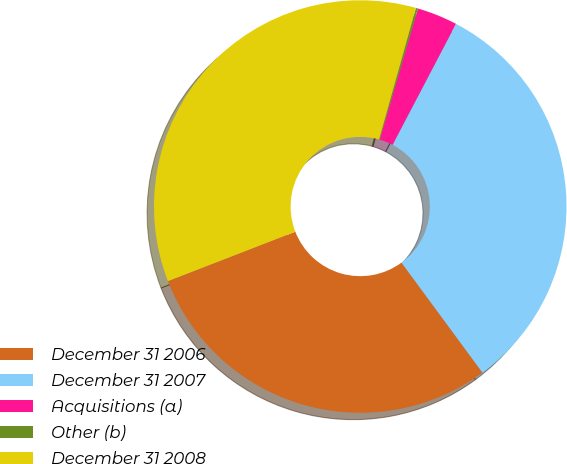Convert chart to OTSL. <chart><loc_0><loc_0><loc_500><loc_500><pie_chart><fcel>December 31 2006<fcel>December 31 2007<fcel>Acquisitions (a)<fcel>Other (b)<fcel>December 31 2008<nl><fcel>29.21%<fcel>32.22%<fcel>3.17%<fcel>0.16%<fcel>35.24%<nl></chart> 